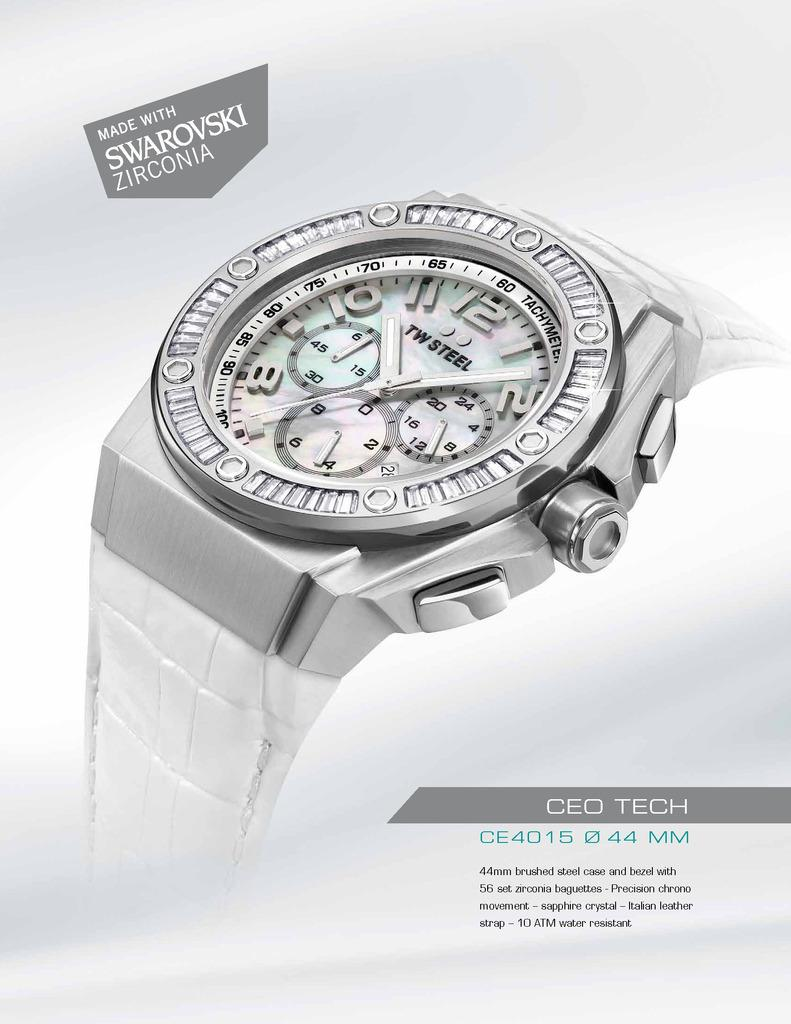<image>
Give a short and clear explanation of the subsequent image. CEO Tech is displayed to the lower right of a silver watch. 